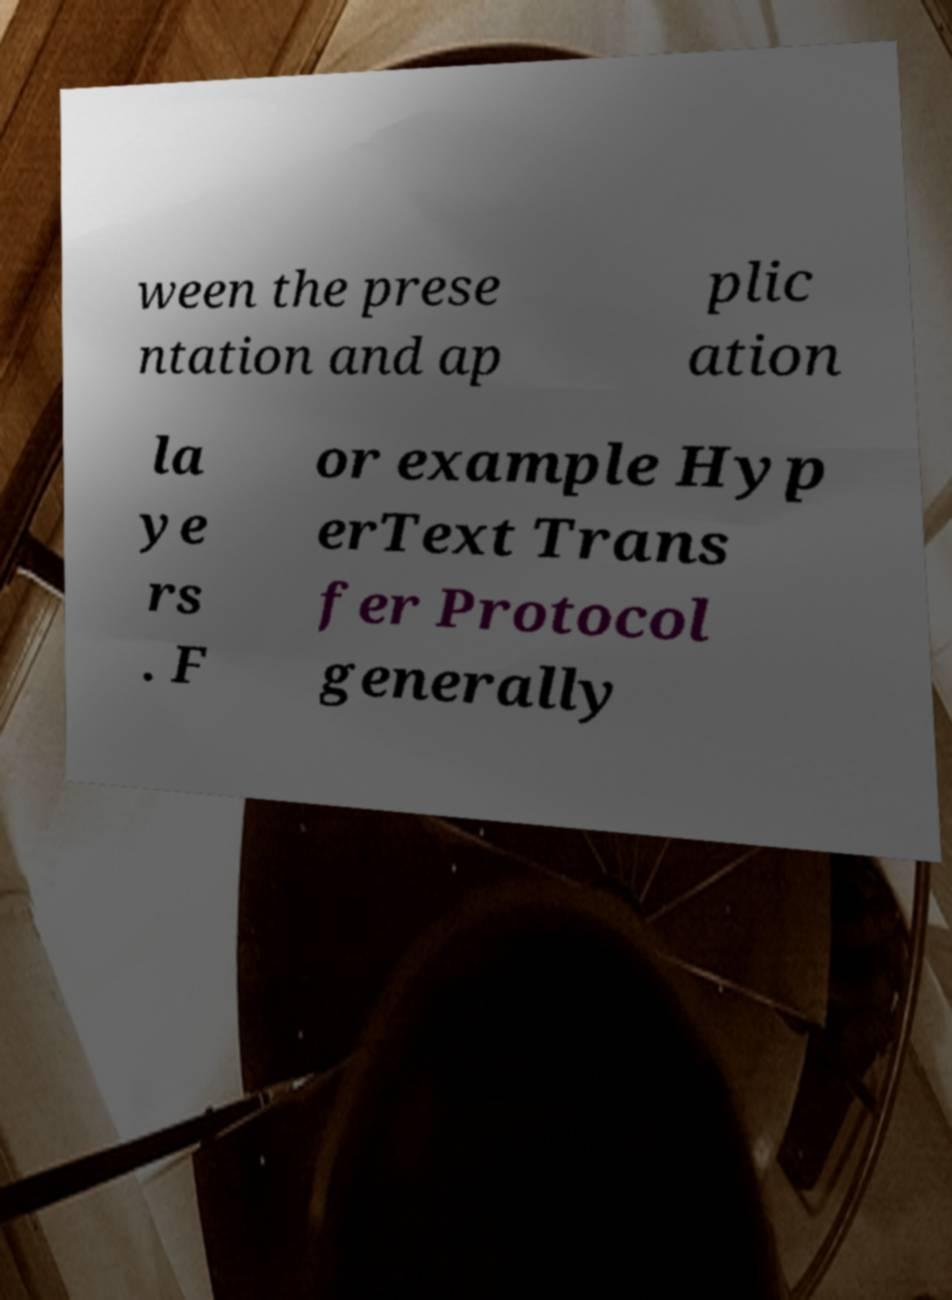Please identify and transcribe the text found in this image. ween the prese ntation and ap plic ation la ye rs . F or example Hyp erText Trans fer Protocol generally 